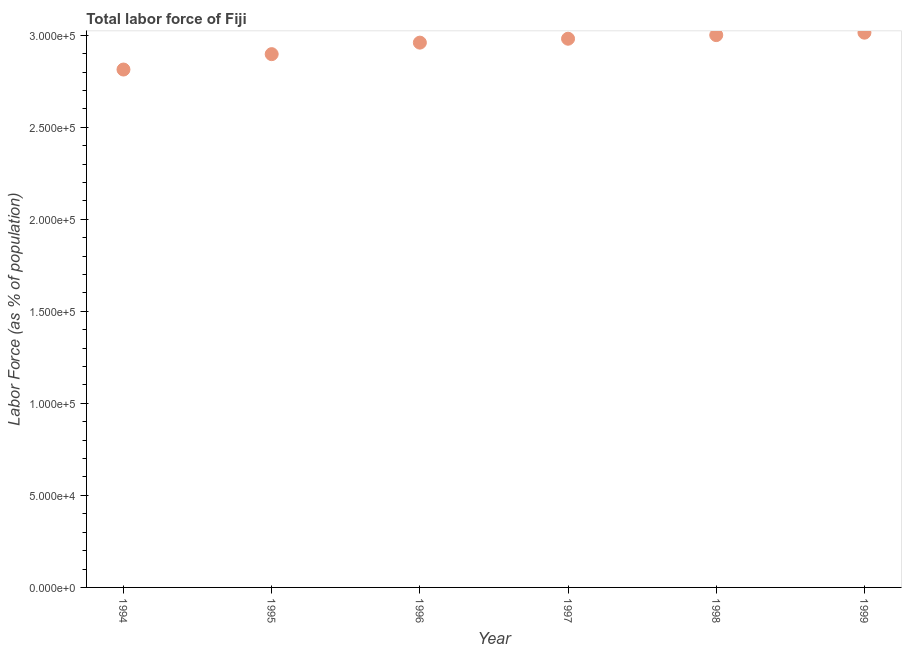What is the total labor force in 1996?
Offer a terse response. 2.96e+05. Across all years, what is the maximum total labor force?
Offer a terse response. 3.01e+05. Across all years, what is the minimum total labor force?
Give a very brief answer. 2.81e+05. In which year was the total labor force maximum?
Keep it short and to the point. 1999. In which year was the total labor force minimum?
Your response must be concise. 1994. What is the sum of the total labor force?
Your answer should be very brief. 1.77e+06. What is the difference between the total labor force in 1995 and 1999?
Give a very brief answer. -1.17e+04. What is the average total labor force per year?
Provide a short and direct response. 2.94e+05. What is the median total labor force?
Ensure brevity in your answer.  2.97e+05. Do a majority of the years between 1997 and 1999 (inclusive) have total labor force greater than 280000 %?
Your response must be concise. Yes. What is the ratio of the total labor force in 1995 to that in 1997?
Make the answer very short. 0.97. Is the total labor force in 1994 less than that in 1995?
Your response must be concise. Yes. Is the difference between the total labor force in 1995 and 1996 greater than the difference between any two years?
Your response must be concise. No. What is the difference between the highest and the second highest total labor force?
Offer a very short reply. 1322. What is the difference between the highest and the lowest total labor force?
Keep it short and to the point. 2.00e+04. How many dotlines are there?
Your answer should be compact. 1. What is the difference between two consecutive major ticks on the Y-axis?
Your answer should be compact. 5.00e+04. Are the values on the major ticks of Y-axis written in scientific E-notation?
Provide a short and direct response. Yes. Does the graph contain grids?
Make the answer very short. No. What is the title of the graph?
Ensure brevity in your answer.  Total labor force of Fiji. What is the label or title of the Y-axis?
Ensure brevity in your answer.  Labor Force (as % of population). What is the Labor Force (as % of population) in 1994?
Your answer should be very brief. 2.81e+05. What is the Labor Force (as % of population) in 1995?
Offer a very short reply. 2.90e+05. What is the Labor Force (as % of population) in 1996?
Make the answer very short. 2.96e+05. What is the Labor Force (as % of population) in 1997?
Your answer should be compact. 2.98e+05. What is the Labor Force (as % of population) in 1998?
Your answer should be very brief. 3.00e+05. What is the Labor Force (as % of population) in 1999?
Give a very brief answer. 3.01e+05. What is the difference between the Labor Force (as % of population) in 1994 and 1995?
Your answer should be compact. -8361. What is the difference between the Labor Force (as % of population) in 1994 and 1996?
Make the answer very short. -1.46e+04. What is the difference between the Labor Force (as % of population) in 1994 and 1997?
Offer a terse response. -1.67e+04. What is the difference between the Labor Force (as % of population) in 1994 and 1998?
Provide a succinct answer. -1.87e+04. What is the difference between the Labor Force (as % of population) in 1994 and 1999?
Your response must be concise. -2.00e+04. What is the difference between the Labor Force (as % of population) in 1995 and 1996?
Ensure brevity in your answer.  -6255. What is the difference between the Labor Force (as % of population) in 1995 and 1997?
Make the answer very short. -8380. What is the difference between the Labor Force (as % of population) in 1995 and 1998?
Make the answer very short. -1.03e+04. What is the difference between the Labor Force (as % of population) in 1995 and 1999?
Offer a very short reply. -1.17e+04. What is the difference between the Labor Force (as % of population) in 1996 and 1997?
Offer a very short reply. -2125. What is the difference between the Labor Force (as % of population) in 1996 and 1998?
Your answer should be very brief. -4092. What is the difference between the Labor Force (as % of population) in 1996 and 1999?
Provide a succinct answer. -5414. What is the difference between the Labor Force (as % of population) in 1997 and 1998?
Your answer should be compact. -1967. What is the difference between the Labor Force (as % of population) in 1997 and 1999?
Provide a succinct answer. -3289. What is the difference between the Labor Force (as % of population) in 1998 and 1999?
Ensure brevity in your answer.  -1322. What is the ratio of the Labor Force (as % of population) in 1994 to that in 1995?
Ensure brevity in your answer.  0.97. What is the ratio of the Labor Force (as % of population) in 1994 to that in 1996?
Give a very brief answer. 0.95. What is the ratio of the Labor Force (as % of population) in 1994 to that in 1997?
Provide a succinct answer. 0.94. What is the ratio of the Labor Force (as % of population) in 1994 to that in 1998?
Your answer should be compact. 0.94. What is the ratio of the Labor Force (as % of population) in 1994 to that in 1999?
Make the answer very short. 0.93. What is the ratio of the Labor Force (as % of population) in 1995 to that in 1998?
Ensure brevity in your answer.  0.97. What is the ratio of the Labor Force (as % of population) in 1995 to that in 1999?
Keep it short and to the point. 0.96. What is the ratio of the Labor Force (as % of population) in 1996 to that in 1998?
Offer a terse response. 0.99. 